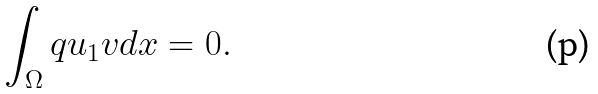<formula> <loc_0><loc_0><loc_500><loc_500>\int _ { \Omega } q u _ { 1 } v d x = 0 .</formula> 